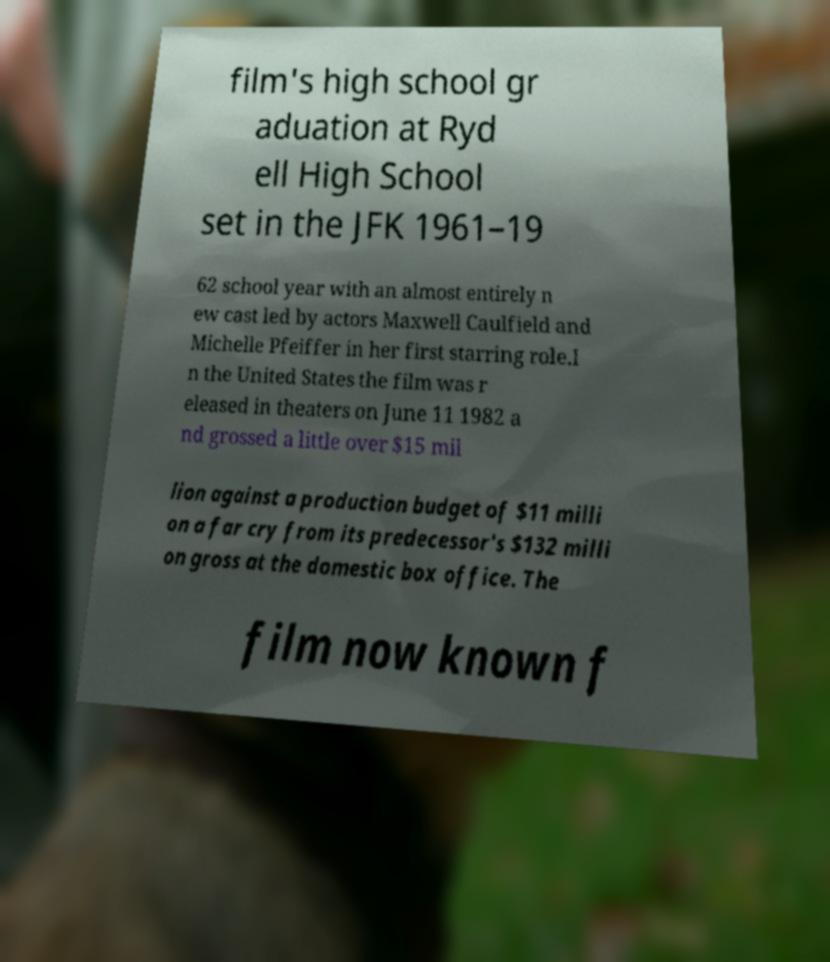I need the written content from this picture converted into text. Can you do that? film's high school gr aduation at Ryd ell High School set in the JFK 1961–19 62 school year with an almost entirely n ew cast led by actors Maxwell Caulfield and Michelle Pfeiffer in her first starring role.I n the United States the film was r eleased in theaters on June 11 1982 a nd grossed a little over $15 mil lion against a production budget of $11 milli on a far cry from its predecessor's $132 milli on gross at the domestic box office. The film now known f 